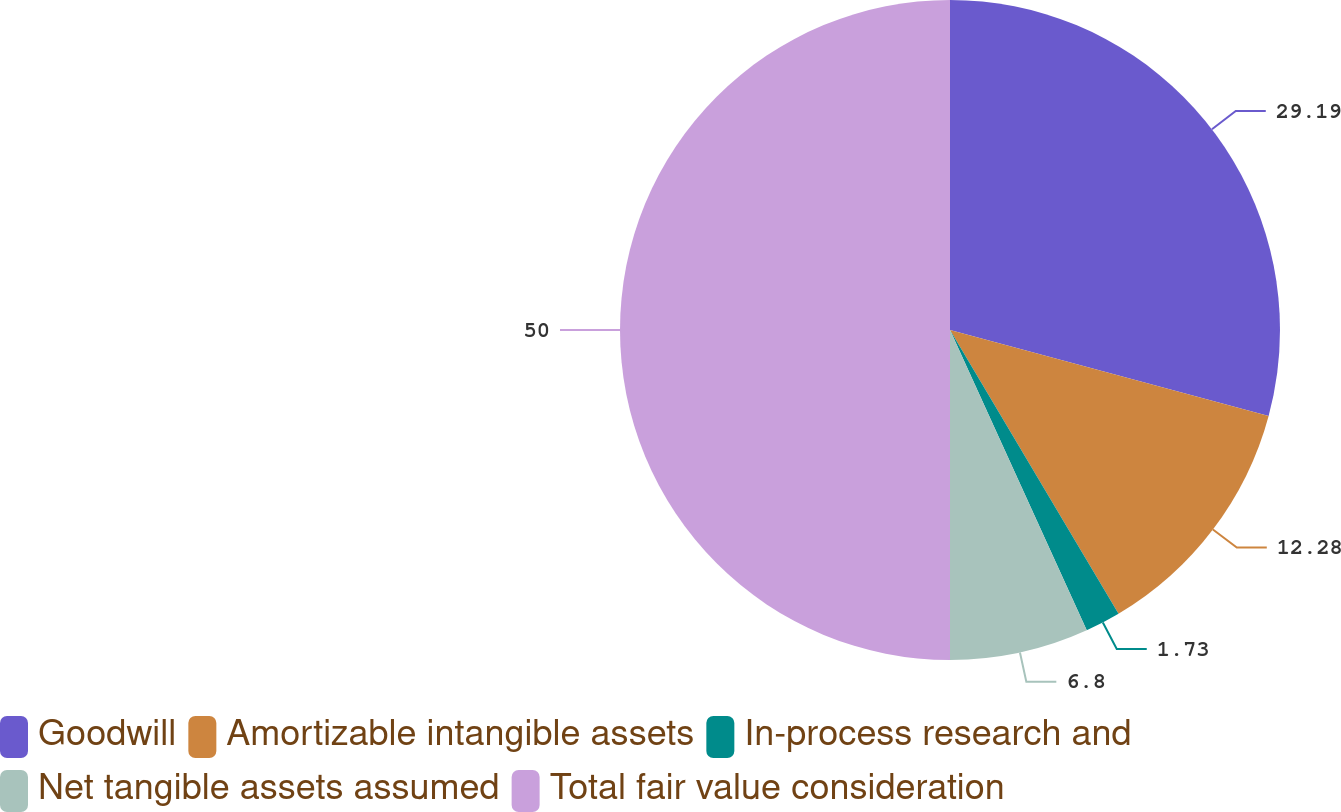Convert chart. <chart><loc_0><loc_0><loc_500><loc_500><pie_chart><fcel>Goodwill<fcel>Amortizable intangible assets<fcel>In-process research and<fcel>Net tangible assets assumed<fcel>Total fair value consideration<nl><fcel>29.19%<fcel>12.28%<fcel>1.73%<fcel>6.8%<fcel>50.0%<nl></chart> 